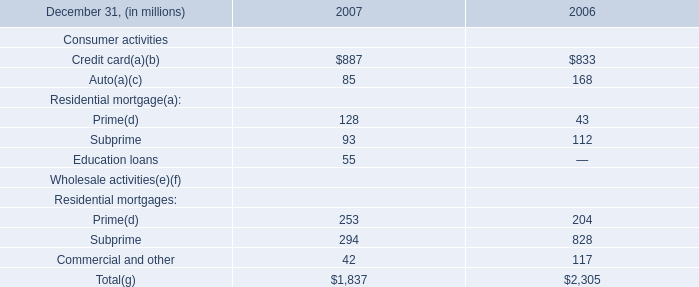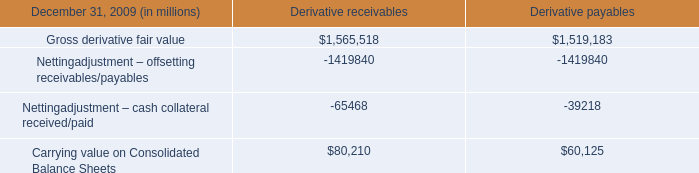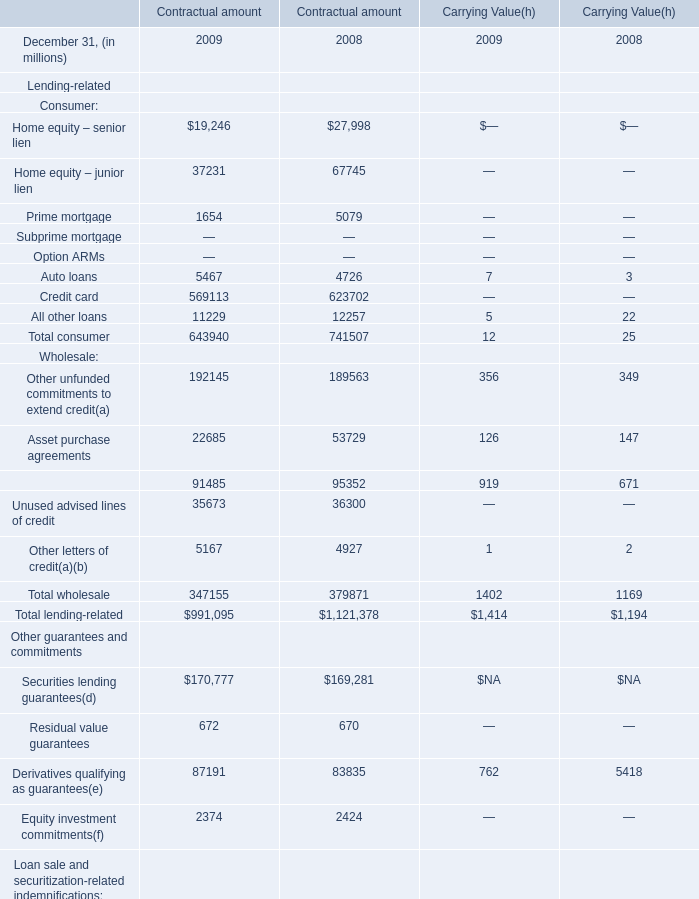In the year with larger Total wholesale at Carrying Value, what is the growth rate of Total lending-related at Carrying Value? 
Computations: ((1414 - 1194) / 1194)
Answer: 0.18425. 